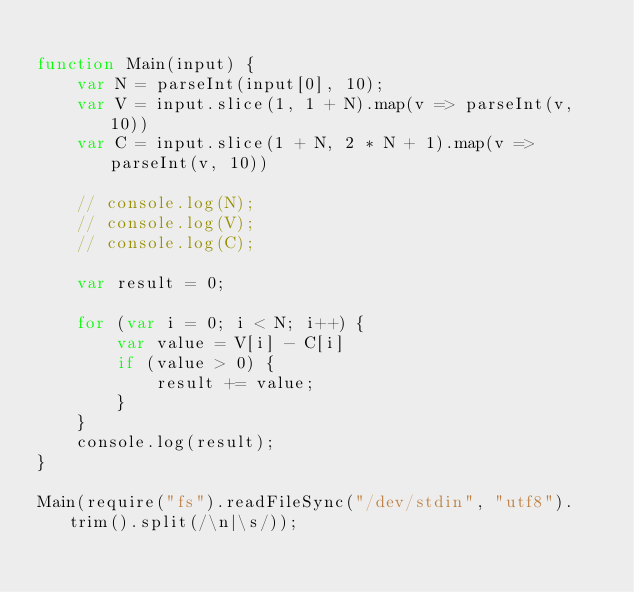<code> <loc_0><loc_0><loc_500><loc_500><_JavaScript_>
function Main(input) {
    var N = parseInt(input[0], 10);
    var V = input.slice(1, 1 + N).map(v => parseInt(v, 10))
    var C = input.slice(1 + N, 2 * N + 1).map(v => parseInt(v, 10))

    // console.log(N);
    // console.log(V);
    // console.log(C);

    var result = 0;

    for (var i = 0; i < N; i++) {
        var value = V[i] - C[i]
        if (value > 0) {
            result += value;
        }
    }
    console.log(result);
}
 
Main(require("fs").readFileSync("/dev/stdin", "utf8").trim().split(/\n|\s/));</code> 